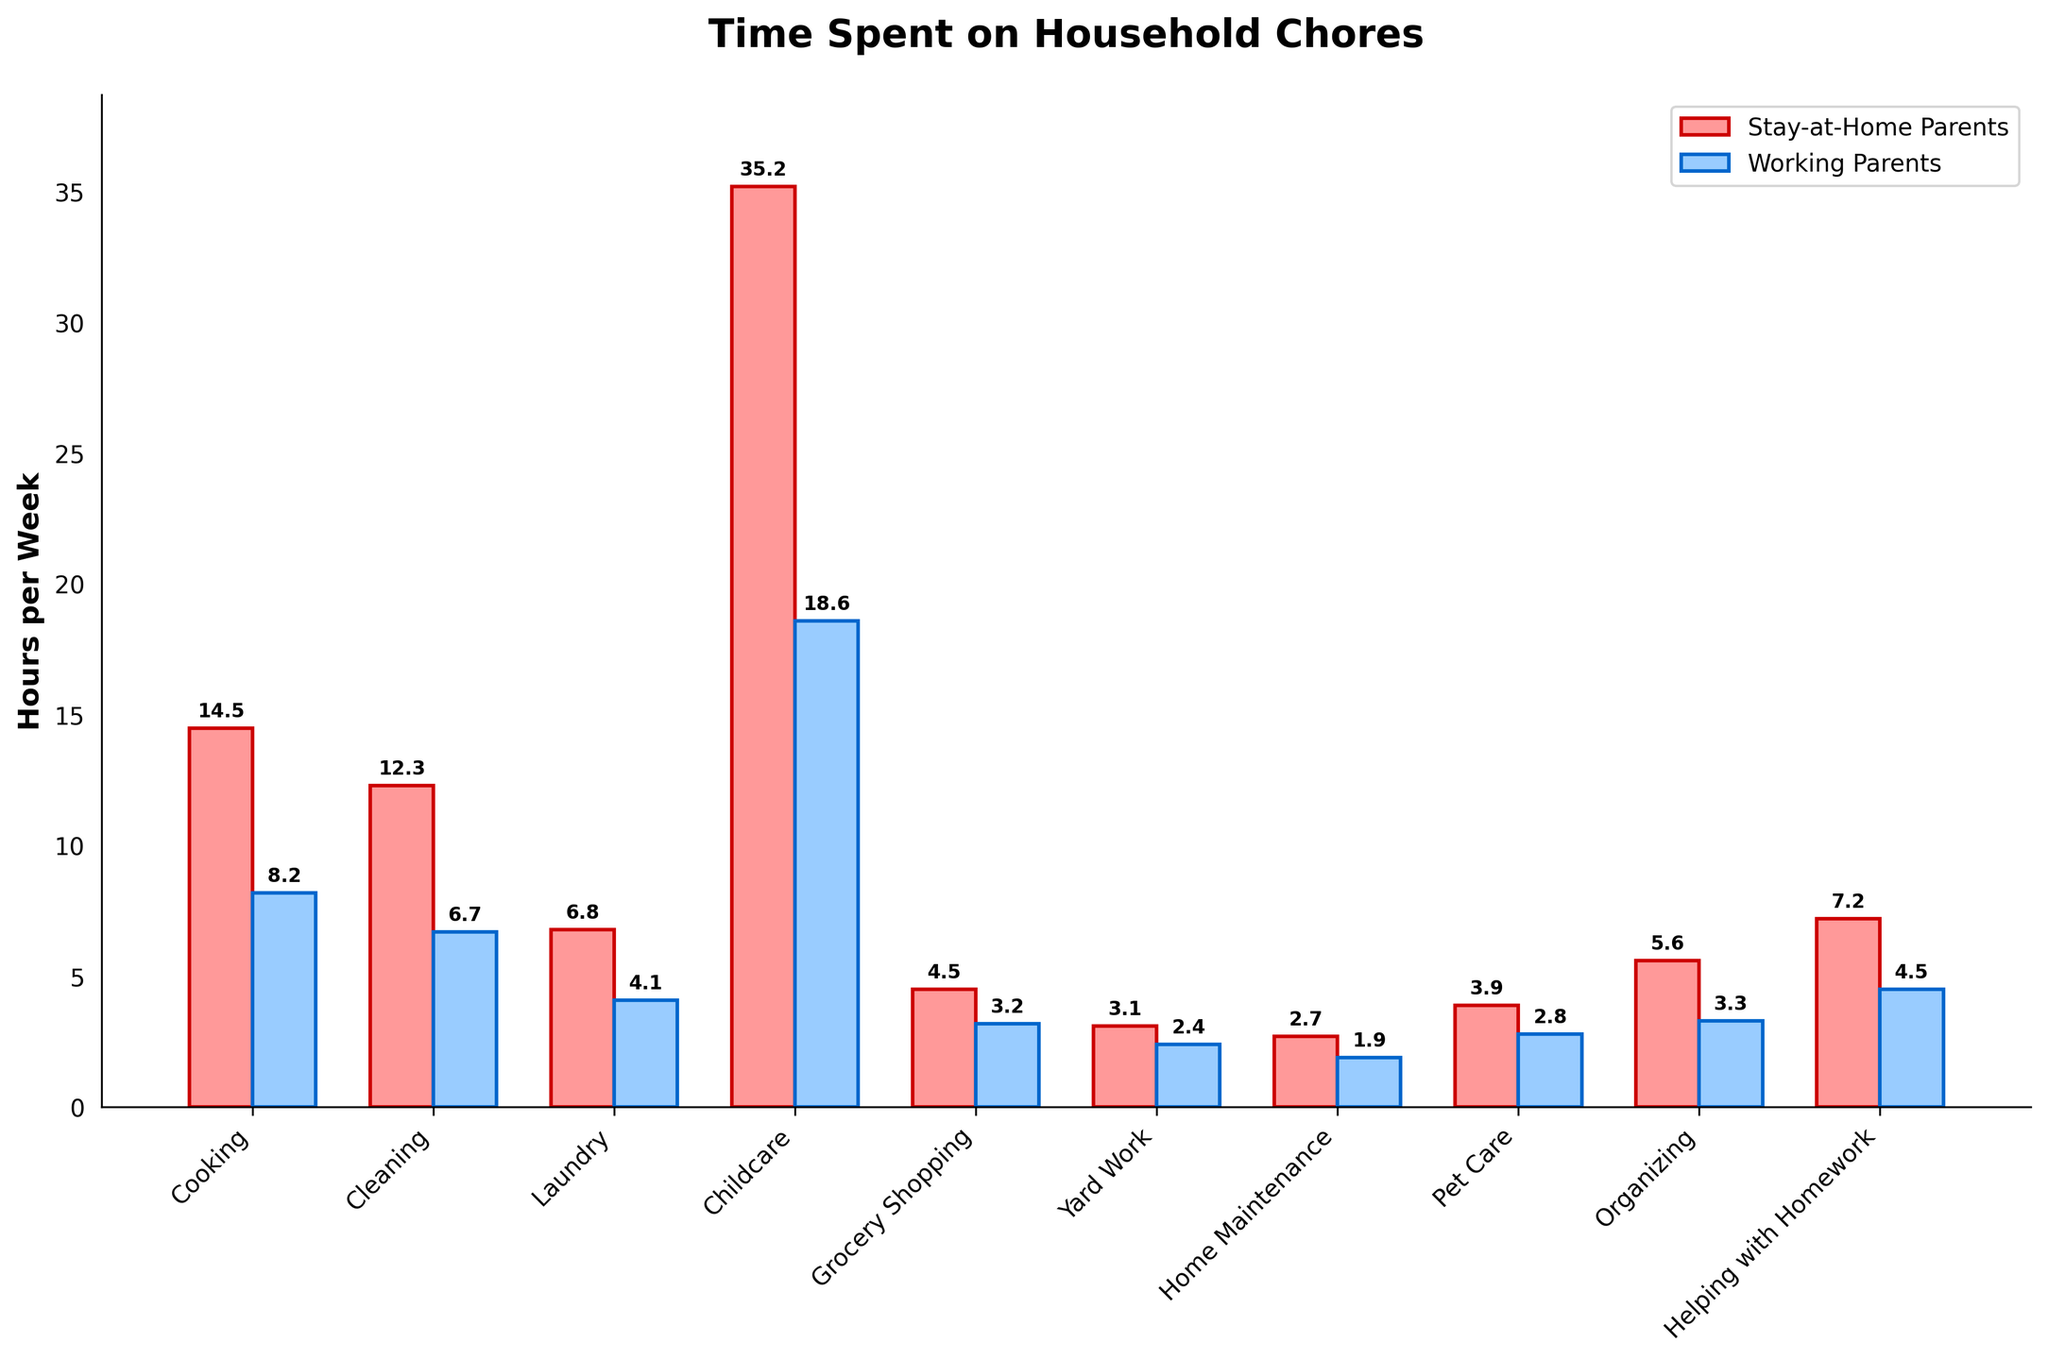How much more time do stay-at-home parents spend on cooking compared to working parents? Stay-at-home parents spend 14.5 hours per week on cooking, while working parents spend 8.2 hours per week. The difference is 14.5 - 8.2 = 6.3 hours.
Answer: 6.3 hours Which activity has the biggest difference in time spent between stay-at-home and working parents? Childcare has the biggest difference in time spent. Stay-at-home parents spend 35.2 hours, and working parents spend 18.6 hours. The difference is 35.2 - 18.6 = 16.6 hours.
Answer: Childcare What's the total time spent on laundry and yard work for stay-at-home parents? Stay-at-home parents spend 6.8 hours on laundry and 3.1 hours on yard work. The total time is 6.8 + 3.1 = 9.9 hours.
Answer: 9.9 hours Do stay-at-home parents spend more or less than twice the time on childcare compared to working parents? Stay-at-home parents spend 35.2 hours on childcare, and working parents spend 18.6 hours. Twice the time for working parents is 18.6 * 2 = 37.2 hours. 35.2 is less than 37.2.
Answer: Less Which parent group spends more time on helping with homework, and by how much? Stay-at-home parents spend 7.2 hours, while working parents spend 4.5 hours on helping with homework. The difference is 7.2 - 4.5 = 2.7 hours.
Answer: Stay-at-home parents by 2.7 hours How much total time do working parents spend on cleaning, grocery shopping, and home maintenance? Working parents spend 6.7 hours on cleaning, 3.2 hours on grocery shopping, and 1.9 hours on home maintenance. The total time is 6.7 + 3.2 + 1.9 = 11.8 hours.
Answer: 11.8 hours Which activity has the smallest difference in time spent between stay-at-home and working parents? Yard work has the smallest difference. Stay-at-home parents spend 3.1 hours, and working parents spend 2.4 hours. The difference is 3.1 - 2.4 = 0.7 hours.
Answer: Yard work Is there any activity where working parents spend more time than stay-at-home parents? By observing the chart, we can see that stay-at-home parents spend more time on every listed activity compared to working parents.
Answer: No What is the average time spent on the listed activities for working parents? Sum up the hours spent on each activity for working parents: 8.2 + 6.7 + 4.1 + 18.6 + 3.2 + 2.4 + 1.9 + 2.8 + 3.3 + 4.5 = 55.7 hours. There are 10 activities, so the average is 55.7 / 10 = 5.57 hours.
Answer: 5.57 hours Which activity do both stay-at-home parents and working parents spend the least time on? From the chart, home maintenance is the activity where both groups spend the least time. Stay-at-home parents spend 2.7 hours, and working parents spend 1.9 hours on it.
Answer: Home maintenance 